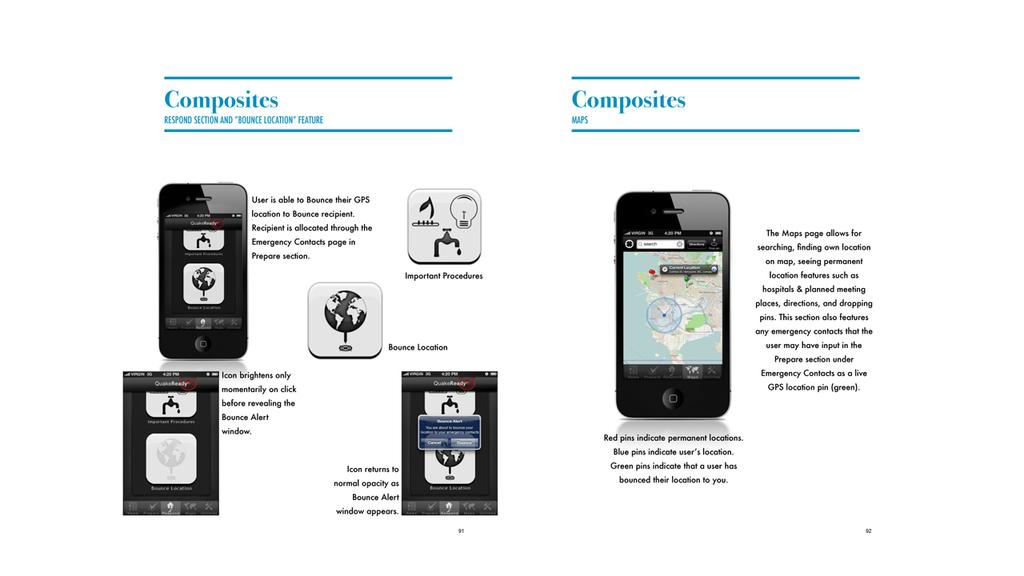Provide a one-sentence caption for the provided image. Composites for a cell phone focus on various features such as GPS and brightness. 